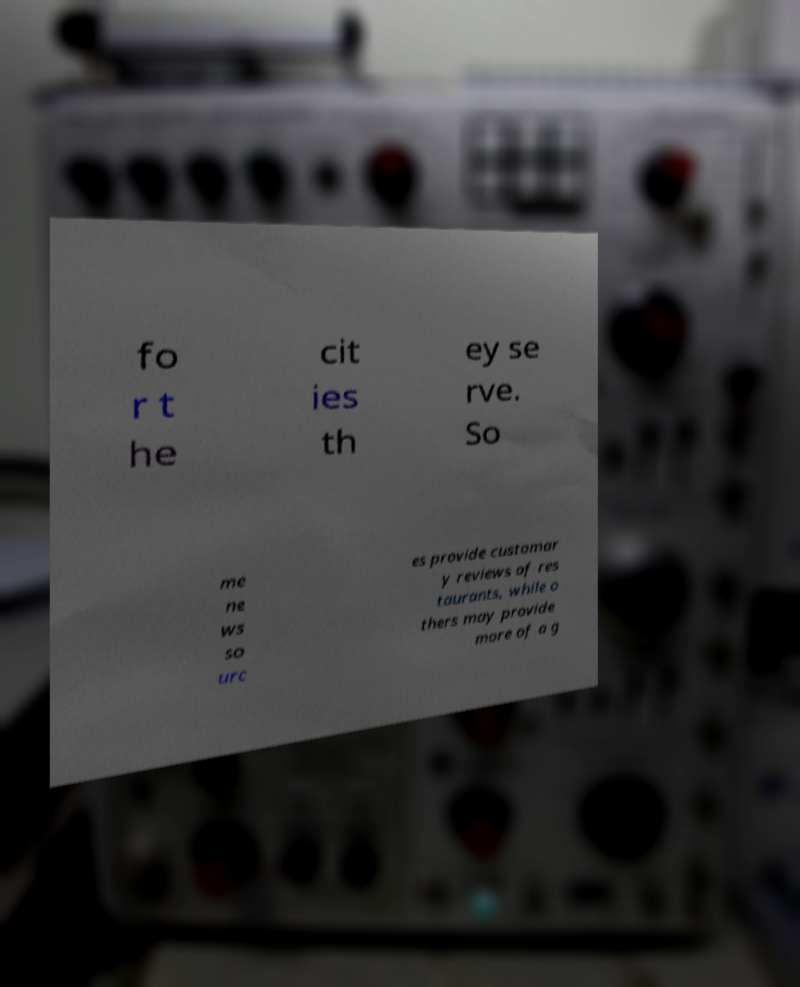Please read and relay the text visible in this image. What does it say? fo r t he cit ies th ey se rve. So me ne ws so urc es provide customar y reviews of res taurants, while o thers may provide more of a g 